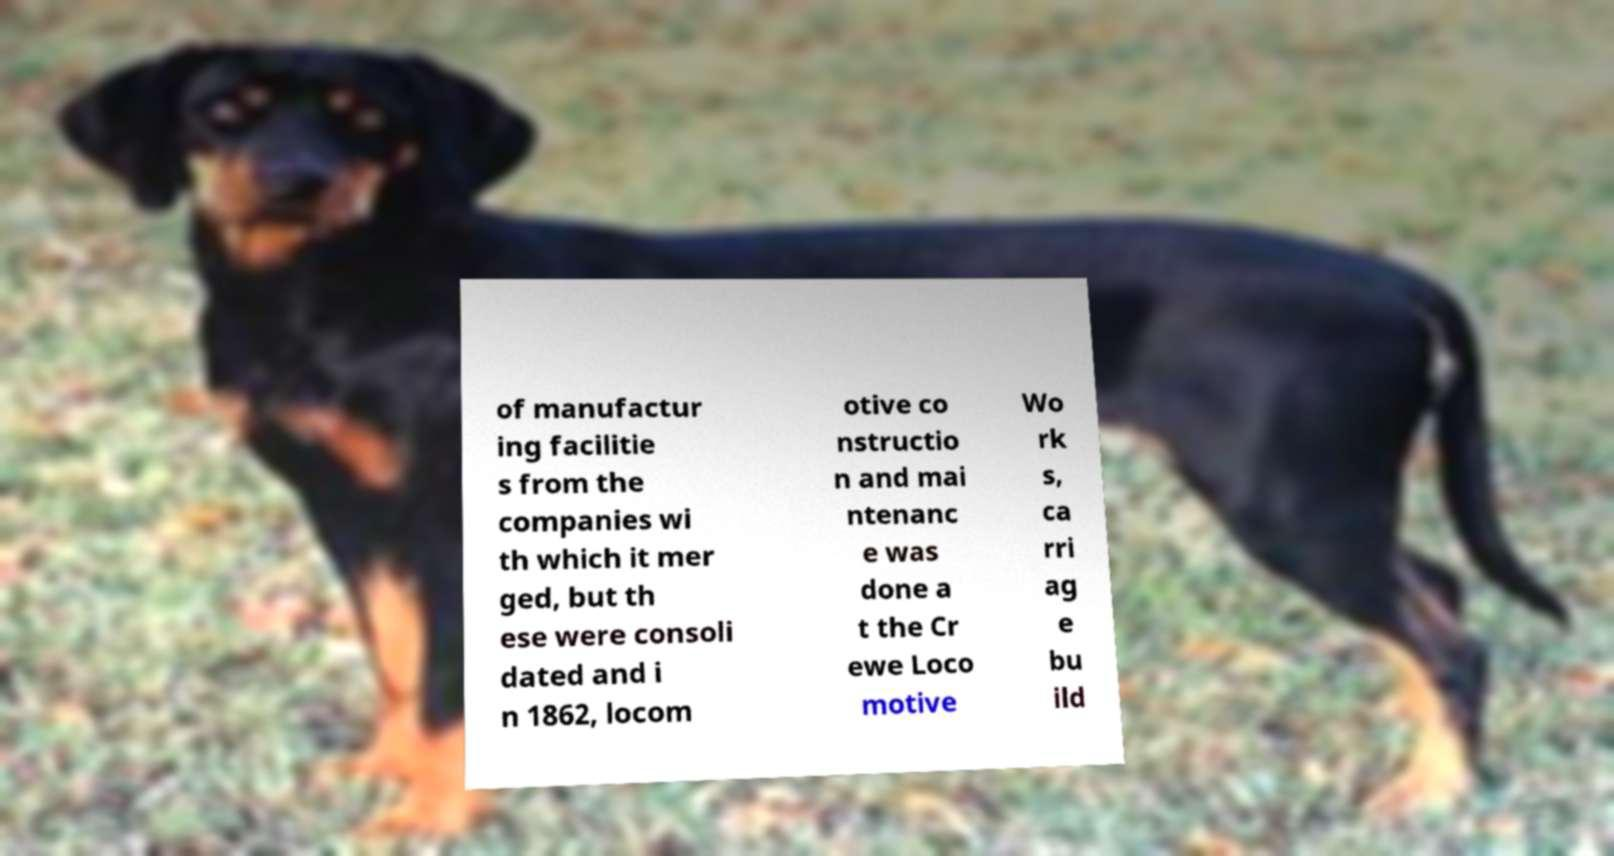There's text embedded in this image that I need extracted. Can you transcribe it verbatim? of manufactur ing facilitie s from the companies wi th which it mer ged, but th ese were consoli dated and i n 1862, locom otive co nstructio n and mai ntenanc e was done a t the Cr ewe Loco motive Wo rk s, ca rri ag e bu ild 